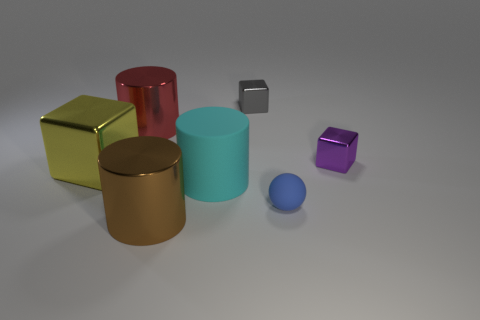Add 2 brown objects. How many objects exist? 9 Subtract all tiny blocks. How many blocks are left? 1 Subtract 1 blocks. How many blocks are left? 2 Subtract all spheres. How many objects are left? 6 Subtract all brown cylinders. Subtract all cyan blocks. How many cylinders are left? 2 Subtract all brown cubes. How many brown cylinders are left? 1 Subtract all tiny purple things. Subtract all tiny matte balls. How many objects are left? 5 Add 6 yellow cubes. How many yellow cubes are left? 7 Add 1 big green objects. How many big green objects exist? 1 Subtract 1 yellow cubes. How many objects are left? 6 